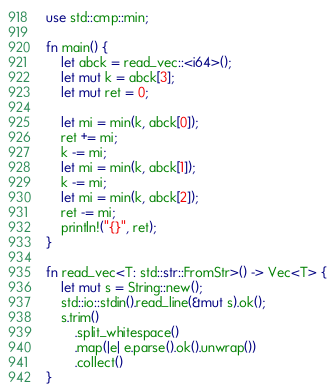<code> <loc_0><loc_0><loc_500><loc_500><_Rust_>use std::cmp::min;

fn main() {
    let abck = read_vec::<i64>();
    let mut k = abck[3];
    let mut ret = 0;

    let mi = min(k, abck[0]);
    ret += mi;
    k -= mi;
    let mi = min(k, abck[1]);
    k -= mi;
    let mi = min(k, abck[2]);
    ret -= mi;
    println!("{}", ret);
}

fn read_vec<T: std::str::FromStr>() -> Vec<T> {
    let mut s = String::new();
    std::io::stdin().read_line(&mut s).ok();
    s.trim()
        .split_whitespace()
        .map(|e| e.parse().ok().unwrap())
        .collect()
}
</code> 